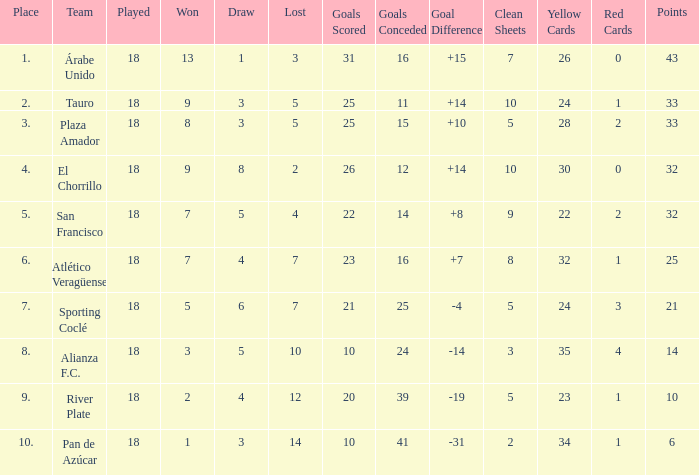How many goals were conceded by teams with 32 points, more than 2 losses and more than 22 goals scored? 0.0. 